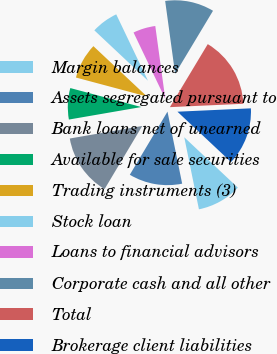Convert chart. <chart><loc_0><loc_0><loc_500><loc_500><pie_chart><fcel>Margin balances<fcel>Assets segregated pursuant to<fcel>Bank loans net of unearned<fcel>Available for sale securities<fcel>Trading instruments (3)<fcel>Stock loan<fcel>Loans to financial advisors<fcel>Corporate cash and all other<fcel>Total<fcel>Brokerage client liabilities<nl><fcel>9.8%<fcel>11.76%<fcel>13.71%<fcel>6.88%<fcel>7.85%<fcel>5.9%<fcel>4.93%<fcel>10.78%<fcel>15.66%<fcel>12.73%<nl></chart> 